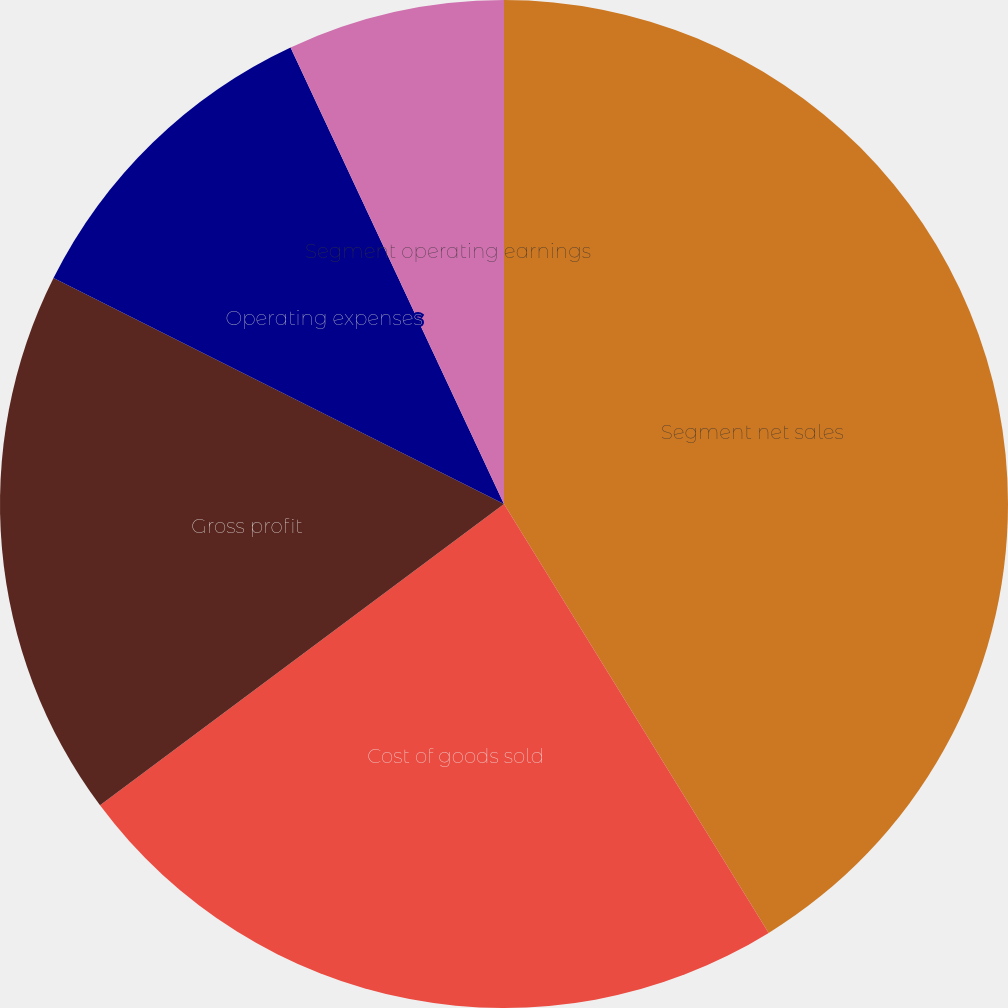Convert chart to OTSL. <chart><loc_0><loc_0><loc_500><loc_500><pie_chart><fcel>Segment net sales<fcel>Cost of goods sold<fcel>Gross profit<fcel>Operating expenses<fcel>Segment operating earnings<nl><fcel>41.2%<fcel>23.6%<fcel>17.6%<fcel>10.64%<fcel>6.96%<nl></chart> 